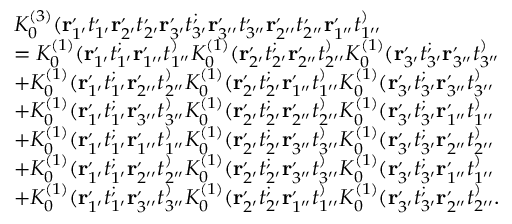<formula> <loc_0><loc_0><loc_500><loc_500>\begin{array} { r l } & { K _ { 0 } ^ { ( 3 ) } ( r _ { 1 ^ { \prime } } ^ { , } t _ { 1 ^ { \prime } } ^ { , } r _ { 2 ^ { \prime } } ^ { , } t _ { 2 ^ { \prime } } ^ { , } r _ { 3 ^ { \prime } } ^ { , } t _ { 3 ^ { \prime } } ^ { ; } r _ { 3 ^ { \prime \prime } } ^ { , } t _ { 3 ^ { \prime \prime } } ^ { , } r _ { 2 ^ { \prime \prime } } ^ { , } t _ { 2 ^ { \prime \prime } } ^ { , } r _ { 1 ^ { \prime \prime } } ^ { , } t _ { 1 ^ { \prime \prime } } ^ { ) } } \\ & { = K _ { 0 } ^ { ( 1 ) } ( r _ { 1 ^ { \prime } } ^ { , } t _ { 1 ^ { \prime } } ^ { ; } r _ { 1 ^ { \prime \prime } } ^ { , } t _ { 1 ^ { \prime \prime } } ^ { ) } K _ { 0 } ^ { ( 1 ) } ( r _ { 2 ^ { \prime } } ^ { , } t _ { 2 ^ { \prime } } ^ { ; } r _ { 2 ^ { \prime \prime } } ^ { , } t _ { 2 ^ { \prime \prime } } ^ { ) } K _ { 0 } ^ { ( 1 ) } ( r _ { 3 ^ { \prime } } ^ { , } t _ { 3 ^ { \prime } } ^ { ; } r _ { 3 ^ { \prime \prime } } ^ { , } t _ { 3 ^ { \prime \prime } } ^ { ) } } \\ & { + K _ { 0 } ^ { ( 1 ) } ( r _ { 1 ^ { \prime } } ^ { , } t _ { 1 ^ { \prime } } ^ { ; } r _ { 2 ^ { \prime \prime } } ^ { , } t _ { 2 ^ { \prime \prime } } ^ { ) } K _ { 0 } ^ { ( 1 ) } ( r _ { 2 ^ { \prime } } ^ { , } t _ { 2 ^ { \prime } } ^ { ; } r _ { 1 ^ { \prime \prime } } ^ { , } t _ { 1 ^ { \prime \prime } } ^ { ) } K _ { 0 } ^ { ( 1 ) } ( r _ { 3 ^ { \prime } } ^ { , } t _ { 3 ^ { \prime } } ^ { ; } r _ { 3 ^ { \prime \prime } } ^ { , } t _ { 3 ^ { \prime \prime } } ^ { ) } } \\ & { + K _ { 0 } ^ { ( 1 ) } ( r _ { 1 ^ { \prime } } ^ { , } t _ { 1 ^ { \prime } } ^ { ; } r _ { 3 ^ { \prime \prime } } ^ { , } t _ { 3 ^ { \prime \prime } } ^ { ) } K _ { 0 } ^ { ( 1 ) } ( r _ { 2 ^ { \prime } } ^ { , } t _ { 2 ^ { \prime } } ^ { ; } r _ { 2 ^ { \prime \prime } } ^ { , } t _ { 2 ^ { \prime \prime } } ^ { ) } K _ { 0 } ^ { ( 1 ) } ( r _ { 3 ^ { \prime } } ^ { , } t _ { 3 ^ { \prime } } ^ { ; } r _ { 1 ^ { \prime \prime } } ^ { , } t _ { 1 ^ { \prime \prime } } ^ { ) } } \\ & { + K _ { 0 } ^ { ( 1 ) } ( r _ { 1 ^ { \prime } } ^ { , } t _ { 1 ^ { \prime } } ^ { ; } r _ { 1 ^ { \prime \prime } } ^ { , } t _ { 1 ^ { \prime \prime } } ^ { ) } K _ { 0 } ^ { ( 1 ) } ( r _ { 2 ^ { \prime } } ^ { , } t _ { 2 ^ { \prime } } ^ { ; } r _ { 3 ^ { \prime \prime } } ^ { , } t _ { 3 ^ { \prime \prime } } ^ { ) } K _ { 0 } ^ { ( 1 ) } ( r _ { 3 ^ { \prime } } ^ { , } t _ { 3 ^ { \prime } } ^ { ; } r _ { 2 ^ { \prime \prime } } ^ { , } t _ { 2 ^ { \prime \prime } } ^ { ) } } \\ & { + K _ { 0 } ^ { ( 1 ) } ( r _ { 1 ^ { \prime } } ^ { , } t _ { 1 ^ { \prime } } ^ { ; } r _ { 2 ^ { \prime \prime } } ^ { , } t _ { 2 ^ { \prime \prime } } ^ { ) } K _ { 0 } ^ { ( 1 ) } ( r _ { 2 ^ { \prime } } ^ { , } t _ { 2 ^ { \prime } } ^ { ; } r _ { 3 ^ { \prime \prime } } ^ { , } t _ { 3 ^ { \prime \prime } } ^ { ) } K _ { 0 } ^ { ( 1 ) } ( r _ { 3 ^ { \prime } } ^ { , } t _ { 3 ^ { \prime } } ^ { ; } r _ { 1 ^ { \prime \prime } } ^ { , } t _ { 1 ^ { \prime \prime } } ^ { ) } } \\ & { + K _ { 0 } ^ { ( 1 ) } ( r _ { 1 ^ { \prime } } ^ { , } t _ { 1 ^ { \prime } } ^ { ; } r _ { 3 ^ { \prime \prime } } ^ { , } t _ { 3 ^ { \prime \prime } } ^ { ) } K _ { 0 } ^ { ( 1 ) } ( r _ { 2 ^ { \prime } } ^ { , } t _ { 2 ^ { \prime } } ^ { ; } r _ { 1 ^ { \prime \prime } } ^ { , } t _ { 1 ^ { \prime \prime } } ^ { ) } K _ { 0 } ^ { ( 1 ) } ( r _ { 3 ^ { \prime } } ^ { , } t _ { 3 ^ { \prime } } ^ { ; } r _ { 2 ^ { \prime \prime } } ^ { , } t _ { 2 ^ { \prime \prime } } ^ { ) } . } \end{array}</formula> 